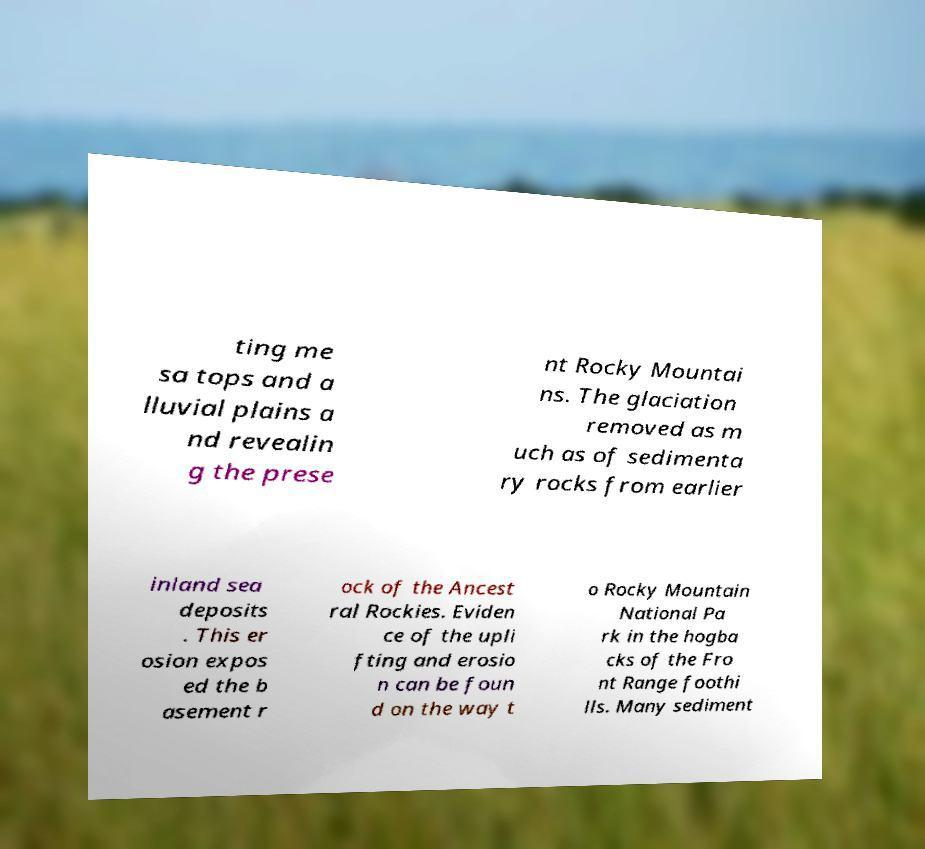For documentation purposes, I need the text within this image transcribed. Could you provide that? ting me sa tops and a lluvial plains a nd revealin g the prese nt Rocky Mountai ns. The glaciation removed as m uch as of sedimenta ry rocks from earlier inland sea deposits . This er osion expos ed the b asement r ock of the Ancest ral Rockies. Eviden ce of the upli fting and erosio n can be foun d on the way t o Rocky Mountain National Pa rk in the hogba cks of the Fro nt Range foothi lls. Many sediment 